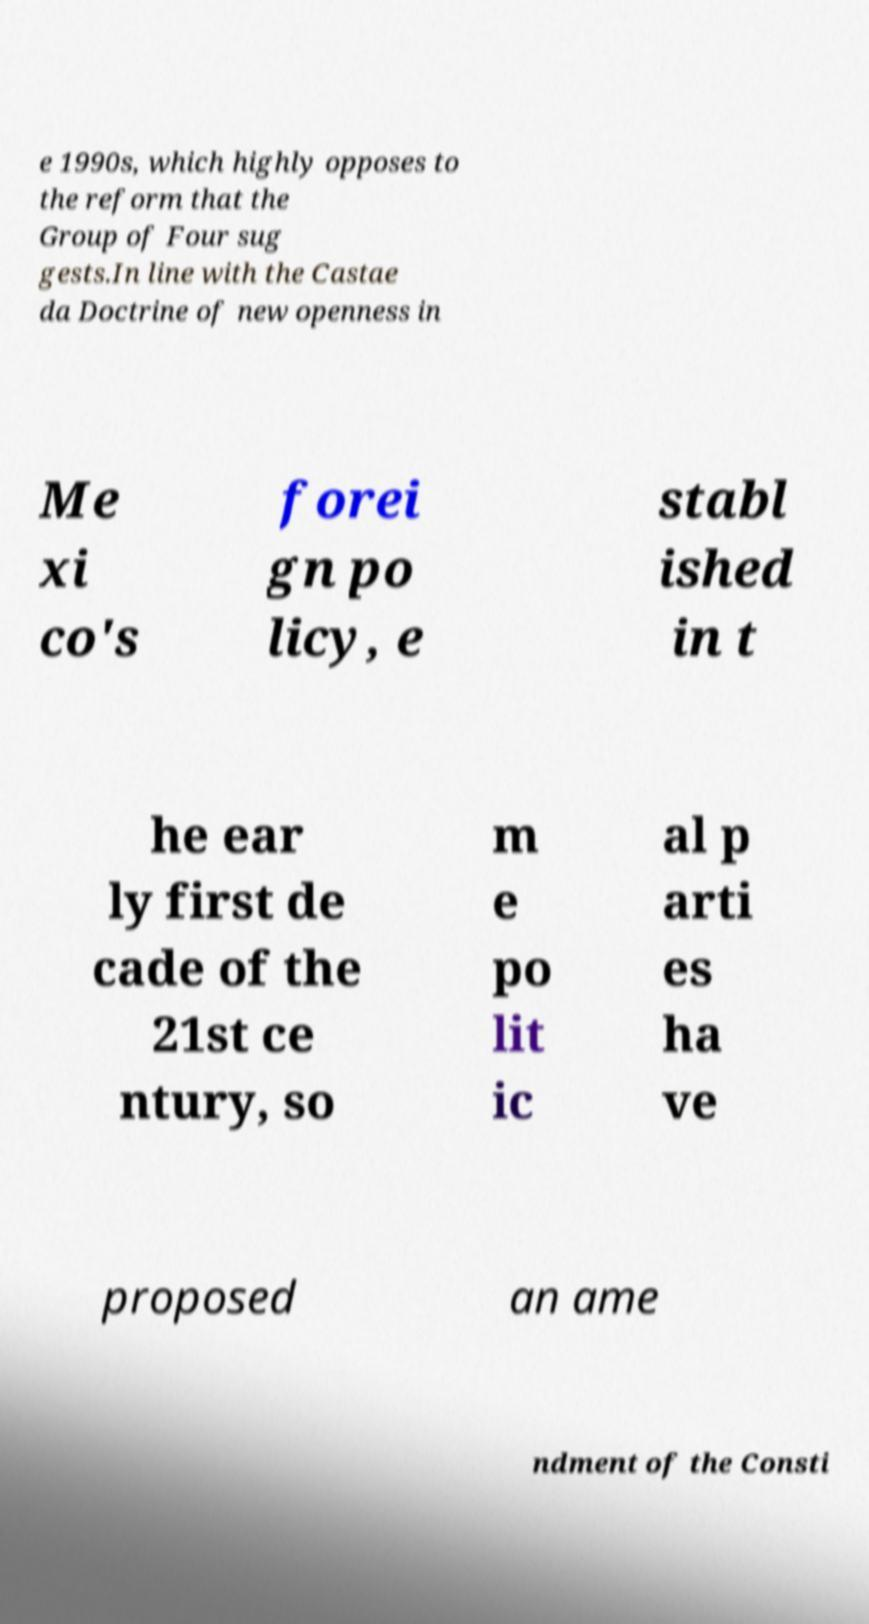What messages or text are displayed in this image? I need them in a readable, typed format. e 1990s, which highly opposes to the reform that the Group of Four sug gests.In line with the Castae da Doctrine of new openness in Me xi co's forei gn po licy, e stabl ished in t he ear ly first de cade of the 21st ce ntury, so m e po lit ic al p arti es ha ve proposed an ame ndment of the Consti 